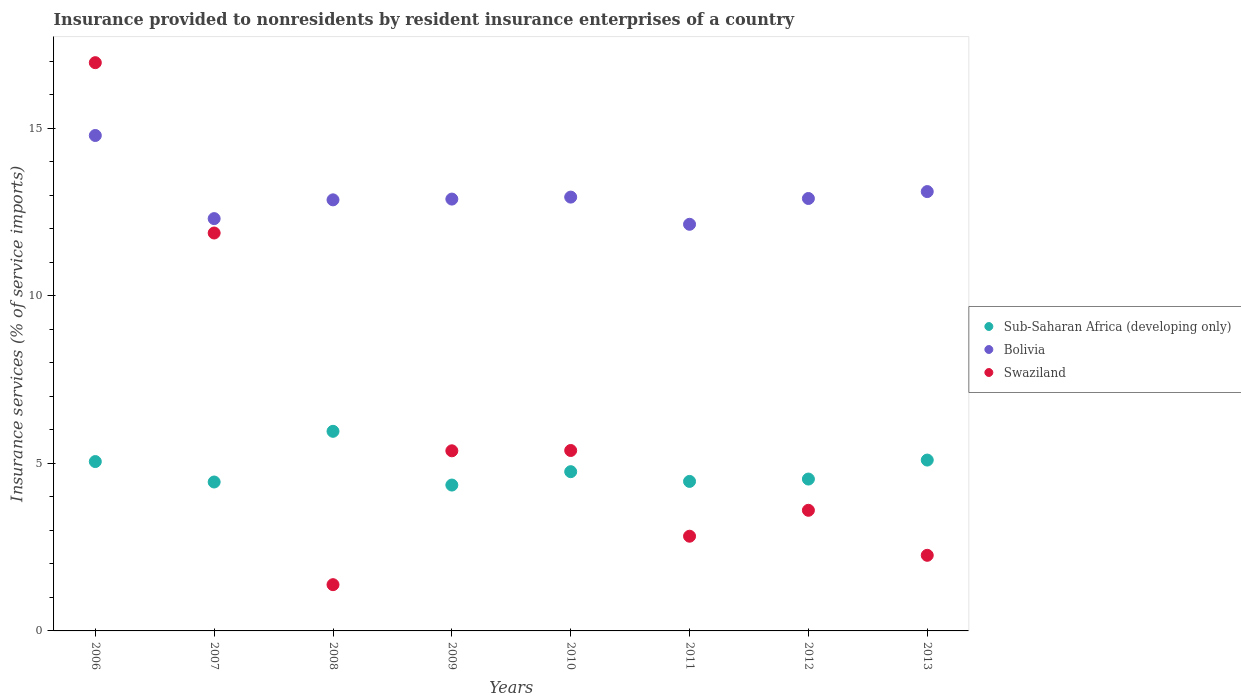What is the insurance provided to nonresidents in Swaziland in 2006?
Give a very brief answer. 16.96. Across all years, what is the maximum insurance provided to nonresidents in Bolivia?
Keep it short and to the point. 14.79. Across all years, what is the minimum insurance provided to nonresidents in Sub-Saharan Africa (developing only)?
Your answer should be very brief. 4.35. What is the total insurance provided to nonresidents in Swaziland in the graph?
Give a very brief answer. 49.66. What is the difference between the insurance provided to nonresidents in Sub-Saharan Africa (developing only) in 2009 and that in 2011?
Give a very brief answer. -0.11. What is the difference between the insurance provided to nonresidents in Swaziland in 2012 and the insurance provided to nonresidents in Sub-Saharan Africa (developing only) in 2009?
Provide a short and direct response. -0.75. What is the average insurance provided to nonresidents in Sub-Saharan Africa (developing only) per year?
Offer a very short reply. 4.83. In the year 2009, what is the difference between the insurance provided to nonresidents in Sub-Saharan Africa (developing only) and insurance provided to nonresidents in Swaziland?
Provide a succinct answer. -1.02. What is the ratio of the insurance provided to nonresidents in Swaziland in 2010 to that in 2011?
Offer a terse response. 1.91. Is the insurance provided to nonresidents in Swaziland in 2006 less than that in 2007?
Provide a short and direct response. No. What is the difference between the highest and the second highest insurance provided to nonresidents in Bolivia?
Make the answer very short. 1.67. What is the difference between the highest and the lowest insurance provided to nonresidents in Swaziland?
Your answer should be compact. 15.58. Is the sum of the insurance provided to nonresidents in Bolivia in 2008 and 2009 greater than the maximum insurance provided to nonresidents in Swaziland across all years?
Your answer should be compact. Yes. Is it the case that in every year, the sum of the insurance provided to nonresidents in Swaziland and insurance provided to nonresidents in Sub-Saharan Africa (developing only)  is greater than the insurance provided to nonresidents in Bolivia?
Provide a succinct answer. No. Is the insurance provided to nonresidents in Swaziland strictly less than the insurance provided to nonresidents in Bolivia over the years?
Ensure brevity in your answer.  No. How many dotlines are there?
Give a very brief answer. 3. How many years are there in the graph?
Give a very brief answer. 8. Does the graph contain any zero values?
Offer a very short reply. No. Where does the legend appear in the graph?
Your response must be concise. Center right. How many legend labels are there?
Provide a succinct answer. 3. What is the title of the graph?
Give a very brief answer. Insurance provided to nonresidents by resident insurance enterprises of a country. What is the label or title of the Y-axis?
Make the answer very short. Insurance services (% of service imports). What is the Insurance services (% of service imports) in Sub-Saharan Africa (developing only) in 2006?
Offer a terse response. 5.05. What is the Insurance services (% of service imports) in Bolivia in 2006?
Provide a short and direct response. 14.79. What is the Insurance services (% of service imports) of Swaziland in 2006?
Make the answer very short. 16.96. What is the Insurance services (% of service imports) in Sub-Saharan Africa (developing only) in 2007?
Keep it short and to the point. 4.44. What is the Insurance services (% of service imports) in Bolivia in 2007?
Give a very brief answer. 12.31. What is the Insurance services (% of service imports) in Swaziland in 2007?
Your answer should be very brief. 11.88. What is the Insurance services (% of service imports) in Sub-Saharan Africa (developing only) in 2008?
Give a very brief answer. 5.96. What is the Insurance services (% of service imports) of Bolivia in 2008?
Ensure brevity in your answer.  12.87. What is the Insurance services (% of service imports) of Swaziland in 2008?
Provide a succinct answer. 1.38. What is the Insurance services (% of service imports) in Sub-Saharan Africa (developing only) in 2009?
Your answer should be very brief. 4.35. What is the Insurance services (% of service imports) of Bolivia in 2009?
Provide a succinct answer. 12.89. What is the Insurance services (% of service imports) in Swaziland in 2009?
Give a very brief answer. 5.38. What is the Insurance services (% of service imports) in Sub-Saharan Africa (developing only) in 2010?
Provide a short and direct response. 4.75. What is the Insurance services (% of service imports) in Bolivia in 2010?
Offer a terse response. 12.95. What is the Insurance services (% of service imports) in Swaziland in 2010?
Provide a succinct answer. 5.38. What is the Insurance services (% of service imports) of Sub-Saharan Africa (developing only) in 2011?
Your answer should be compact. 4.46. What is the Insurance services (% of service imports) of Bolivia in 2011?
Give a very brief answer. 12.14. What is the Insurance services (% of service imports) in Swaziland in 2011?
Offer a terse response. 2.83. What is the Insurance services (% of service imports) of Sub-Saharan Africa (developing only) in 2012?
Offer a terse response. 4.53. What is the Insurance services (% of service imports) in Bolivia in 2012?
Give a very brief answer. 12.91. What is the Insurance services (% of service imports) in Swaziland in 2012?
Provide a succinct answer. 3.6. What is the Insurance services (% of service imports) in Sub-Saharan Africa (developing only) in 2013?
Offer a very short reply. 5.1. What is the Insurance services (% of service imports) in Bolivia in 2013?
Provide a succinct answer. 13.11. What is the Insurance services (% of service imports) in Swaziland in 2013?
Your response must be concise. 2.26. Across all years, what is the maximum Insurance services (% of service imports) in Sub-Saharan Africa (developing only)?
Keep it short and to the point. 5.96. Across all years, what is the maximum Insurance services (% of service imports) of Bolivia?
Give a very brief answer. 14.79. Across all years, what is the maximum Insurance services (% of service imports) of Swaziland?
Keep it short and to the point. 16.96. Across all years, what is the minimum Insurance services (% of service imports) in Sub-Saharan Africa (developing only)?
Provide a succinct answer. 4.35. Across all years, what is the minimum Insurance services (% of service imports) of Bolivia?
Your response must be concise. 12.14. Across all years, what is the minimum Insurance services (% of service imports) in Swaziland?
Keep it short and to the point. 1.38. What is the total Insurance services (% of service imports) of Sub-Saharan Africa (developing only) in the graph?
Provide a succinct answer. 38.66. What is the total Insurance services (% of service imports) of Bolivia in the graph?
Your answer should be compact. 103.95. What is the total Insurance services (% of service imports) in Swaziland in the graph?
Ensure brevity in your answer.  49.66. What is the difference between the Insurance services (% of service imports) of Sub-Saharan Africa (developing only) in 2006 and that in 2007?
Offer a terse response. 0.61. What is the difference between the Insurance services (% of service imports) in Bolivia in 2006 and that in 2007?
Your answer should be very brief. 2.48. What is the difference between the Insurance services (% of service imports) of Swaziland in 2006 and that in 2007?
Offer a terse response. 5.08. What is the difference between the Insurance services (% of service imports) in Sub-Saharan Africa (developing only) in 2006 and that in 2008?
Provide a short and direct response. -0.9. What is the difference between the Insurance services (% of service imports) of Bolivia in 2006 and that in 2008?
Your response must be concise. 1.92. What is the difference between the Insurance services (% of service imports) in Swaziland in 2006 and that in 2008?
Offer a terse response. 15.58. What is the difference between the Insurance services (% of service imports) in Sub-Saharan Africa (developing only) in 2006 and that in 2009?
Provide a short and direct response. 0.7. What is the difference between the Insurance services (% of service imports) of Bolivia in 2006 and that in 2009?
Give a very brief answer. 1.9. What is the difference between the Insurance services (% of service imports) in Swaziland in 2006 and that in 2009?
Keep it short and to the point. 11.58. What is the difference between the Insurance services (% of service imports) in Sub-Saharan Africa (developing only) in 2006 and that in 2010?
Offer a very short reply. 0.3. What is the difference between the Insurance services (% of service imports) in Bolivia in 2006 and that in 2010?
Your answer should be very brief. 1.84. What is the difference between the Insurance services (% of service imports) in Swaziland in 2006 and that in 2010?
Make the answer very short. 11.57. What is the difference between the Insurance services (% of service imports) in Sub-Saharan Africa (developing only) in 2006 and that in 2011?
Give a very brief answer. 0.59. What is the difference between the Insurance services (% of service imports) in Bolivia in 2006 and that in 2011?
Your response must be concise. 2.65. What is the difference between the Insurance services (% of service imports) in Swaziland in 2006 and that in 2011?
Provide a succinct answer. 14.13. What is the difference between the Insurance services (% of service imports) in Sub-Saharan Africa (developing only) in 2006 and that in 2012?
Provide a short and direct response. 0.52. What is the difference between the Insurance services (% of service imports) in Bolivia in 2006 and that in 2012?
Provide a succinct answer. 1.88. What is the difference between the Insurance services (% of service imports) in Swaziland in 2006 and that in 2012?
Your answer should be compact. 13.36. What is the difference between the Insurance services (% of service imports) of Sub-Saharan Africa (developing only) in 2006 and that in 2013?
Your response must be concise. -0.04. What is the difference between the Insurance services (% of service imports) of Bolivia in 2006 and that in 2013?
Keep it short and to the point. 1.67. What is the difference between the Insurance services (% of service imports) of Swaziland in 2006 and that in 2013?
Give a very brief answer. 14.7. What is the difference between the Insurance services (% of service imports) of Sub-Saharan Africa (developing only) in 2007 and that in 2008?
Make the answer very short. -1.51. What is the difference between the Insurance services (% of service imports) of Bolivia in 2007 and that in 2008?
Your answer should be very brief. -0.56. What is the difference between the Insurance services (% of service imports) in Swaziland in 2007 and that in 2008?
Offer a terse response. 10.5. What is the difference between the Insurance services (% of service imports) in Sub-Saharan Africa (developing only) in 2007 and that in 2009?
Offer a very short reply. 0.09. What is the difference between the Insurance services (% of service imports) of Bolivia in 2007 and that in 2009?
Ensure brevity in your answer.  -0.58. What is the difference between the Insurance services (% of service imports) in Swaziland in 2007 and that in 2009?
Offer a terse response. 6.5. What is the difference between the Insurance services (% of service imports) of Sub-Saharan Africa (developing only) in 2007 and that in 2010?
Provide a short and direct response. -0.31. What is the difference between the Insurance services (% of service imports) of Bolivia in 2007 and that in 2010?
Provide a succinct answer. -0.64. What is the difference between the Insurance services (% of service imports) in Swaziland in 2007 and that in 2010?
Offer a very short reply. 6.49. What is the difference between the Insurance services (% of service imports) in Sub-Saharan Africa (developing only) in 2007 and that in 2011?
Provide a short and direct response. -0.02. What is the difference between the Insurance services (% of service imports) in Bolivia in 2007 and that in 2011?
Your answer should be very brief. 0.17. What is the difference between the Insurance services (% of service imports) in Swaziland in 2007 and that in 2011?
Offer a very short reply. 9.05. What is the difference between the Insurance services (% of service imports) of Sub-Saharan Africa (developing only) in 2007 and that in 2012?
Provide a succinct answer. -0.09. What is the difference between the Insurance services (% of service imports) in Bolivia in 2007 and that in 2012?
Offer a terse response. -0.6. What is the difference between the Insurance services (% of service imports) of Swaziland in 2007 and that in 2012?
Give a very brief answer. 8.28. What is the difference between the Insurance services (% of service imports) in Sub-Saharan Africa (developing only) in 2007 and that in 2013?
Your response must be concise. -0.65. What is the difference between the Insurance services (% of service imports) in Bolivia in 2007 and that in 2013?
Your response must be concise. -0.81. What is the difference between the Insurance services (% of service imports) in Swaziland in 2007 and that in 2013?
Your answer should be compact. 9.62. What is the difference between the Insurance services (% of service imports) of Sub-Saharan Africa (developing only) in 2008 and that in 2009?
Your answer should be very brief. 1.6. What is the difference between the Insurance services (% of service imports) of Bolivia in 2008 and that in 2009?
Your answer should be compact. -0.02. What is the difference between the Insurance services (% of service imports) of Swaziland in 2008 and that in 2009?
Your answer should be compact. -4. What is the difference between the Insurance services (% of service imports) in Sub-Saharan Africa (developing only) in 2008 and that in 2010?
Your response must be concise. 1.2. What is the difference between the Insurance services (% of service imports) in Bolivia in 2008 and that in 2010?
Your answer should be very brief. -0.08. What is the difference between the Insurance services (% of service imports) of Swaziland in 2008 and that in 2010?
Give a very brief answer. -4. What is the difference between the Insurance services (% of service imports) of Sub-Saharan Africa (developing only) in 2008 and that in 2011?
Your answer should be very brief. 1.49. What is the difference between the Insurance services (% of service imports) in Bolivia in 2008 and that in 2011?
Offer a terse response. 0.73. What is the difference between the Insurance services (% of service imports) of Swaziland in 2008 and that in 2011?
Give a very brief answer. -1.45. What is the difference between the Insurance services (% of service imports) of Sub-Saharan Africa (developing only) in 2008 and that in 2012?
Your answer should be compact. 1.42. What is the difference between the Insurance services (% of service imports) of Bolivia in 2008 and that in 2012?
Give a very brief answer. -0.04. What is the difference between the Insurance services (% of service imports) in Swaziland in 2008 and that in 2012?
Provide a short and direct response. -2.22. What is the difference between the Insurance services (% of service imports) of Sub-Saharan Africa (developing only) in 2008 and that in 2013?
Your answer should be very brief. 0.86. What is the difference between the Insurance services (% of service imports) in Bolivia in 2008 and that in 2013?
Your answer should be very brief. -0.25. What is the difference between the Insurance services (% of service imports) of Swaziland in 2008 and that in 2013?
Your answer should be very brief. -0.88. What is the difference between the Insurance services (% of service imports) in Sub-Saharan Africa (developing only) in 2009 and that in 2010?
Your response must be concise. -0.4. What is the difference between the Insurance services (% of service imports) in Bolivia in 2009 and that in 2010?
Provide a succinct answer. -0.06. What is the difference between the Insurance services (% of service imports) of Swaziland in 2009 and that in 2010?
Your answer should be very brief. -0.01. What is the difference between the Insurance services (% of service imports) of Sub-Saharan Africa (developing only) in 2009 and that in 2011?
Offer a very short reply. -0.11. What is the difference between the Insurance services (% of service imports) of Bolivia in 2009 and that in 2011?
Offer a very short reply. 0.75. What is the difference between the Insurance services (% of service imports) in Swaziland in 2009 and that in 2011?
Provide a short and direct response. 2.55. What is the difference between the Insurance services (% of service imports) of Sub-Saharan Africa (developing only) in 2009 and that in 2012?
Keep it short and to the point. -0.18. What is the difference between the Insurance services (% of service imports) in Bolivia in 2009 and that in 2012?
Your response must be concise. -0.02. What is the difference between the Insurance services (% of service imports) of Swaziland in 2009 and that in 2012?
Provide a succinct answer. 1.78. What is the difference between the Insurance services (% of service imports) in Sub-Saharan Africa (developing only) in 2009 and that in 2013?
Make the answer very short. -0.75. What is the difference between the Insurance services (% of service imports) in Bolivia in 2009 and that in 2013?
Your answer should be compact. -0.22. What is the difference between the Insurance services (% of service imports) of Swaziland in 2009 and that in 2013?
Offer a very short reply. 3.12. What is the difference between the Insurance services (% of service imports) in Sub-Saharan Africa (developing only) in 2010 and that in 2011?
Your response must be concise. 0.29. What is the difference between the Insurance services (% of service imports) in Bolivia in 2010 and that in 2011?
Provide a short and direct response. 0.81. What is the difference between the Insurance services (% of service imports) in Swaziland in 2010 and that in 2011?
Give a very brief answer. 2.56. What is the difference between the Insurance services (% of service imports) of Sub-Saharan Africa (developing only) in 2010 and that in 2012?
Ensure brevity in your answer.  0.22. What is the difference between the Insurance services (% of service imports) in Bolivia in 2010 and that in 2012?
Give a very brief answer. 0.04. What is the difference between the Insurance services (% of service imports) of Swaziland in 2010 and that in 2012?
Your answer should be very brief. 1.78. What is the difference between the Insurance services (% of service imports) of Sub-Saharan Africa (developing only) in 2010 and that in 2013?
Provide a short and direct response. -0.35. What is the difference between the Insurance services (% of service imports) in Bolivia in 2010 and that in 2013?
Keep it short and to the point. -0.16. What is the difference between the Insurance services (% of service imports) in Swaziland in 2010 and that in 2013?
Provide a succinct answer. 3.13. What is the difference between the Insurance services (% of service imports) in Sub-Saharan Africa (developing only) in 2011 and that in 2012?
Give a very brief answer. -0.07. What is the difference between the Insurance services (% of service imports) of Bolivia in 2011 and that in 2012?
Make the answer very short. -0.77. What is the difference between the Insurance services (% of service imports) in Swaziland in 2011 and that in 2012?
Offer a very short reply. -0.77. What is the difference between the Insurance services (% of service imports) in Sub-Saharan Africa (developing only) in 2011 and that in 2013?
Provide a short and direct response. -0.64. What is the difference between the Insurance services (% of service imports) in Bolivia in 2011 and that in 2013?
Make the answer very short. -0.98. What is the difference between the Insurance services (% of service imports) in Swaziland in 2011 and that in 2013?
Give a very brief answer. 0.57. What is the difference between the Insurance services (% of service imports) in Sub-Saharan Africa (developing only) in 2012 and that in 2013?
Offer a terse response. -0.57. What is the difference between the Insurance services (% of service imports) in Bolivia in 2012 and that in 2013?
Offer a terse response. -0.21. What is the difference between the Insurance services (% of service imports) in Swaziland in 2012 and that in 2013?
Your answer should be compact. 1.34. What is the difference between the Insurance services (% of service imports) in Sub-Saharan Africa (developing only) in 2006 and the Insurance services (% of service imports) in Bolivia in 2007?
Your answer should be very brief. -7.25. What is the difference between the Insurance services (% of service imports) in Sub-Saharan Africa (developing only) in 2006 and the Insurance services (% of service imports) in Swaziland in 2007?
Provide a short and direct response. -6.82. What is the difference between the Insurance services (% of service imports) in Bolivia in 2006 and the Insurance services (% of service imports) in Swaziland in 2007?
Make the answer very short. 2.91. What is the difference between the Insurance services (% of service imports) in Sub-Saharan Africa (developing only) in 2006 and the Insurance services (% of service imports) in Bolivia in 2008?
Your response must be concise. -7.81. What is the difference between the Insurance services (% of service imports) of Sub-Saharan Africa (developing only) in 2006 and the Insurance services (% of service imports) of Swaziland in 2008?
Your answer should be very brief. 3.67. What is the difference between the Insurance services (% of service imports) of Bolivia in 2006 and the Insurance services (% of service imports) of Swaziland in 2008?
Offer a terse response. 13.41. What is the difference between the Insurance services (% of service imports) in Sub-Saharan Africa (developing only) in 2006 and the Insurance services (% of service imports) in Bolivia in 2009?
Offer a very short reply. -7.83. What is the difference between the Insurance services (% of service imports) in Sub-Saharan Africa (developing only) in 2006 and the Insurance services (% of service imports) in Swaziland in 2009?
Give a very brief answer. -0.32. What is the difference between the Insurance services (% of service imports) of Bolivia in 2006 and the Insurance services (% of service imports) of Swaziland in 2009?
Your response must be concise. 9.41. What is the difference between the Insurance services (% of service imports) in Sub-Saharan Africa (developing only) in 2006 and the Insurance services (% of service imports) in Bolivia in 2010?
Provide a short and direct response. -7.89. What is the difference between the Insurance services (% of service imports) of Sub-Saharan Africa (developing only) in 2006 and the Insurance services (% of service imports) of Swaziland in 2010?
Make the answer very short. -0.33. What is the difference between the Insurance services (% of service imports) of Bolivia in 2006 and the Insurance services (% of service imports) of Swaziland in 2010?
Give a very brief answer. 9.4. What is the difference between the Insurance services (% of service imports) in Sub-Saharan Africa (developing only) in 2006 and the Insurance services (% of service imports) in Bolivia in 2011?
Ensure brevity in your answer.  -7.08. What is the difference between the Insurance services (% of service imports) in Sub-Saharan Africa (developing only) in 2006 and the Insurance services (% of service imports) in Swaziland in 2011?
Your answer should be very brief. 2.23. What is the difference between the Insurance services (% of service imports) of Bolivia in 2006 and the Insurance services (% of service imports) of Swaziland in 2011?
Provide a short and direct response. 11.96. What is the difference between the Insurance services (% of service imports) of Sub-Saharan Africa (developing only) in 2006 and the Insurance services (% of service imports) of Bolivia in 2012?
Your response must be concise. -7.85. What is the difference between the Insurance services (% of service imports) in Sub-Saharan Africa (developing only) in 2006 and the Insurance services (% of service imports) in Swaziland in 2012?
Ensure brevity in your answer.  1.45. What is the difference between the Insurance services (% of service imports) in Bolivia in 2006 and the Insurance services (% of service imports) in Swaziland in 2012?
Offer a terse response. 11.19. What is the difference between the Insurance services (% of service imports) of Sub-Saharan Africa (developing only) in 2006 and the Insurance services (% of service imports) of Bolivia in 2013?
Provide a succinct answer. -8.06. What is the difference between the Insurance services (% of service imports) in Sub-Saharan Africa (developing only) in 2006 and the Insurance services (% of service imports) in Swaziland in 2013?
Provide a short and direct response. 2.8. What is the difference between the Insurance services (% of service imports) of Bolivia in 2006 and the Insurance services (% of service imports) of Swaziland in 2013?
Provide a succinct answer. 12.53. What is the difference between the Insurance services (% of service imports) of Sub-Saharan Africa (developing only) in 2007 and the Insurance services (% of service imports) of Bolivia in 2008?
Provide a short and direct response. -8.42. What is the difference between the Insurance services (% of service imports) of Sub-Saharan Africa (developing only) in 2007 and the Insurance services (% of service imports) of Swaziland in 2008?
Give a very brief answer. 3.06. What is the difference between the Insurance services (% of service imports) in Bolivia in 2007 and the Insurance services (% of service imports) in Swaziland in 2008?
Offer a very short reply. 10.93. What is the difference between the Insurance services (% of service imports) in Sub-Saharan Africa (developing only) in 2007 and the Insurance services (% of service imports) in Bolivia in 2009?
Provide a short and direct response. -8.44. What is the difference between the Insurance services (% of service imports) in Sub-Saharan Africa (developing only) in 2007 and the Insurance services (% of service imports) in Swaziland in 2009?
Provide a short and direct response. -0.93. What is the difference between the Insurance services (% of service imports) in Bolivia in 2007 and the Insurance services (% of service imports) in Swaziland in 2009?
Provide a short and direct response. 6.93. What is the difference between the Insurance services (% of service imports) in Sub-Saharan Africa (developing only) in 2007 and the Insurance services (% of service imports) in Bolivia in 2010?
Ensure brevity in your answer.  -8.5. What is the difference between the Insurance services (% of service imports) in Sub-Saharan Africa (developing only) in 2007 and the Insurance services (% of service imports) in Swaziland in 2010?
Ensure brevity in your answer.  -0.94. What is the difference between the Insurance services (% of service imports) of Bolivia in 2007 and the Insurance services (% of service imports) of Swaziland in 2010?
Offer a terse response. 6.92. What is the difference between the Insurance services (% of service imports) of Sub-Saharan Africa (developing only) in 2007 and the Insurance services (% of service imports) of Bolivia in 2011?
Provide a succinct answer. -7.69. What is the difference between the Insurance services (% of service imports) in Sub-Saharan Africa (developing only) in 2007 and the Insurance services (% of service imports) in Swaziland in 2011?
Your answer should be very brief. 1.62. What is the difference between the Insurance services (% of service imports) of Bolivia in 2007 and the Insurance services (% of service imports) of Swaziland in 2011?
Provide a short and direct response. 9.48. What is the difference between the Insurance services (% of service imports) in Sub-Saharan Africa (developing only) in 2007 and the Insurance services (% of service imports) in Bolivia in 2012?
Offer a terse response. -8.46. What is the difference between the Insurance services (% of service imports) in Sub-Saharan Africa (developing only) in 2007 and the Insurance services (% of service imports) in Swaziland in 2012?
Your response must be concise. 0.84. What is the difference between the Insurance services (% of service imports) of Bolivia in 2007 and the Insurance services (% of service imports) of Swaziland in 2012?
Ensure brevity in your answer.  8.71. What is the difference between the Insurance services (% of service imports) in Sub-Saharan Africa (developing only) in 2007 and the Insurance services (% of service imports) in Bolivia in 2013?
Give a very brief answer. -8.67. What is the difference between the Insurance services (% of service imports) in Sub-Saharan Africa (developing only) in 2007 and the Insurance services (% of service imports) in Swaziland in 2013?
Give a very brief answer. 2.19. What is the difference between the Insurance services (% of service imports) in Bolivia in 2007 and the Insurance services (% of service imports) in Swaziland in 2013?
Your answer should be very brief. 10.05. What is the difference between the Insurance services (% of service imports) in Sub-Saharan Africa (developing only) in 2008 and the Insurance services (% of service imports) in Bolivia in 2009?
Offer a terse response. -6.93. What is the difference between the Insurance services (% of service imports) of Sub-Saharan Africa (developing only) in 2008 and the Insurance services (% of service imports) of Swaziland in 2009?
Give a very brief answer. 0.58. What is the difference between the Insurance services (% of service imports) of Bolivia in 2008 and the Insurance services (% of service imports) of Swaziland in 2009?
Your answer should be very brief. 7.49. What is the difference between the Insurance services (% of service imports) of Sub-Saharan Africa (developing only) in 2008 and the Insurance services (% of service imports) of Bolivia in 2010?
Your answer should be very brief. -6.99. What is the difference between the Insurance services (% of service imports) of Sub-Saharan Africa (developing only) in 2008 and the Insurance services (% of service imports) of Swaziland in 2010?
Keep it short and to the point. 0.57. What is the difference between the Insurance services (% of service imports) in Bolivia in 2008 and the Insurance services (% of service imports) in Swaziland in 2010?
Keep it short and to the point. 7.48. What is the difference between the Insurance services (% of service imports) of Sub-Saharan Africa (developing only) in 2008 and the Insurance services (% of service imports) of Bolivia in 2011?
Keep it short and to the point. -6.18. What is the difference between the Insurance services (% of service imports) of Sub-Saharan Africa (developing only) in 2008 and the Insurance services (% of service imports) of Swaziland in 2011?
Provide a short and direct response. 3.13. What is the difference between the Insurance services (% of service imports) in Bolivia in 2008 and the Insurance services (% of service imports) in Swaziland in 2011?
Your answer should be very brief. 10.04. What is the difference between the Insurance services (% of service imports) in Sub-Saharan Africa (developing only) in 2008 and the Insurance services (% of service imports) in Bolivia in 2012?
Give a very brief answer. -6.95. What is the difference between the Insurance services (% of service imports) of Sub-Saharan Africa (developing only) in 2008 and the Insurance services (% of service imports) of Swaziland in 2012?
Give a very brief answer. 2.36. What is the difference between the Insurance services (% of service imports) of Bolivia in 2008 and the Insurance services (% of service imports) of Swaziland in 2012?
Your answer should be very brief. 9.27. What is the difference between the Insurance services (% of service imports) in Sub-Saharan Africa (developing only) in 2008 and the Insurance services (% of service imports) in Bolivia in 2013?
Ensure brevity in your answer.  -7.16. What is the difference between the Insurance services (% of service imports) in Sub-Saharan Africa (developing only) in 2008 and the Insurance services (% of service imports) in Swaziland in 2013?
Your answer should be compact. 3.7. What is the difference between the Insurance services (% of service imports) of Bolivia in 2008 and the Insurance services (% of service imports) of Swaziland in 2013?
Make the answer very short. 10.61. What is the difference between the Insurance services (% of service imports) in Sub-Saharan Africa (developing only) in 2009 and the Insurance services (% of service imports) in Bolivia in 2010?
Provide a succinct answer. -8.59. What is the difference between the Insurance services (% of service imports) of Sub-Saharan Africa (developing only) in 2009 and the Insurance services (% of service imports) of Swaziland in 2010?
Your answer should be very brief. -1.03. What is the difference between the Insurance services (% of service imports) in Bolivia in 2009 and the Insurance services (% of service imports) in Swaziland in 2010?
Your answer should be very brief. 7.5. What is the difference between the Insurance services (% of service imports) of Sub-Saharan Africa (developing only) in 2009 and the Insurance services (% of service imports) of Bolivia in 2011?
Your answer should be compact. -7.78. What is the difference between the Insurance services (% of service imports) in Sub-Saharan Africa (developing only) in 2009 and the Insurance services (% of service imports) in Swaziland in 2011?
Offer a very short reply. 1.53. What is the difference between the Insurance services (% of service imports) of Bolivia in 2009 and the Insurance services (% of service imports) of Swaziland in 2011?
Make the answer very short. 10.06. What is the difference between the Insurance services (% of service imports) of Sub-Saharan Africa (developing only) in 2009 and the Insurance services (% of service imports) of Bolivia in 2012?
Your answer should be very brief. -8.55. What is the difference between the Insurance services (% of service imports) of Sub-Saharan Africa (developing only) in 2009 and the Insurance services (% of service imports) of Swaziland in 2012?
Make the answer very short. 0.75. What is the difference between the Insurance services (% of service imports) of Bolivia in 2009 and the Insurance services (% of service imports) of Swaziland in 2012?
Ensure brevity in your answer.  9.29. What is the difference between the Insurance services (% of service imports) in Sub-Saharan Africa (developing only) in 2009 and the Insurance services (% of service imports) in Bolivia in 2013?
Keep it short and to the point. -8.76. What is the difference between the Insurance services (% of service imports) of Sub-Saharan Africa (developing only) in 2009 and the Insurance services (% of service imports) of Swaziland in 2013?
Give a very brief answer. 2.1. What is the difference between the Insurance services (% of service imports) in Bolivia in 2009 and the Insurance services (% of service imports) in Swaziland in 2013?
Your answer should be compact. 10.63. What is the difference between the Insurance services (% of service imports) of Sub-Saharan Africa (developing only) in 2010 and the Insurance services (% of service imports) of Bolivia in 2011?
Your answer should be compact. -7.38. What is the difference between the Insurance services (% of service imports) of Sub-Saharan Africa (developing only) in 2010 and the Insurance services (% of service imports) of Swaziland in 2011?
Ensure brevity in your answer.  1.93. What is the difference between the Insurance services (% of service imports) in Bolivia in 2010 and the Insurance services (% of service imports) in Swaziland in 2011?
Give a very brief answer. 10.12. What is the difference between the Insurance services (% of service imports) of Sub-Saharan Africa (developing only) in 2010 and the Insurance services (% of service imports) of Bolivia in 2012?
Provide a succinct answer. -8.15. What is the difference between the Insurance services (% of service imports) of Sub-Saharan Africa (developing only) in 2010 and the Insurance services (% of service imports) of Swaziland in 2012?
Your response must be concise. 1.15. What is the difference between the Insurance services (% of service imports) of Bolivia in 2010 and the Insurance services (% of service imports) of Swaziland in 2012?
Offer a very short reply. 9.35. What is the difference between the Insurance services (% of service imports) of Sub-Saharan Africa (developing only) in 2010 and the Insurance services (% of service imports) of Bolivia in 2013?
Offer a terse response. -8.36. What is the difference between the Insurance services (% of service imports) in Sub-Saharan Africa (developing only) in 2010 and the Insurance services (% of service imports) in Swaziland in 2013?
Offer a terse response. 2.5. What is the difference between the Insurance services (% of service imports) of Bolivia in 2010 and the Insurance services (% of service imports) of Swaziland in 2013?
Provide a succinct answer. 10.69. What is the difference between the Insurance services (% of service imports) in Sub-Saharan Africa (developing only) in 2011 and the Insurance services (% of service imports) in Bolivia in 2012?
Ensure brevity in your answer.  -8.44. What is the difference between the Insurance services (% of service imports) in Sub-Saharan Africa (developing only) in 2011 and the Insurance services (% of service imports) in Swaziland in 2012?
Offer a terse response. 0.86. What is the difference between the Insurance services (% of service imports) in Bolivia in 2011 and the Insurance services (% of service imports) in Swaziland in 2012?
Offer a terse response. 8.54. What is the difference between the Insurance services (% of service imports) of Sub-Saharan Africa (developing only) in 2011 and the Insurance services (% of service imports) of Bolivia in 2013?
Your answer should be compact. -8.65. What is the difference between the Insurance services (% of service imports) of Sub-Saharan Africa (developing only) in 2011 and the Insurance services (% of service imports) of Swaziland in 2013?
Give a very brief answer. 2.21. What is the difference between the Insurance services (% of service imports) in Bolivia in 2011 and the Insurance services (% of service imports) in Swaziland in 2013?
Your answer should be very brief. 9.88. What is the difference between the Insurance services (% of service imports) of Sub-Saharan Africa (developing only) in 2012 and the Insurance services (% of service imports) of Bolivia in 2013?
Provide a short and direct response. -8.58. What is the difference between the Insurance services (% of service imports) of Sub-Saharan Africa (developing only) in 2012 and the Insurance services (% of service imports) of Swaziland in 2013?
Offer a very short reply. 2.28. What is the difference between the Insurance services (% of service imports) of Bolivia in 2012 and the Insurance services (% of service imports) of Swaziland in 2013?
Your response must be concise. 10.65. What is the average Insurance services (% of service imports) of Sub-Saharan Africa (developing only) per year?
Your answer should be very brief. 4.83. What is the average Insurance services (% of service imports) of Bolivia per year?
Offer a terse response. 12.99. What is the average Insurance services (% of service imports) in Swaziland per year?
Provide a succinct answer. 6.21. In the year 2006, what is the difference between the Insurance services (% of service imports) of Sub-Saharan Africa (developing only) and Insurance services (% of service imports) of Bolivia?
Keep it short and to the point. -9.73. In the year 2006, what is the difference between the Insurance services (% of service imports) of Sub-Saharan Africa (developing only) and Insurance services (% of service imports) of Swaziland?
Your response must be concise. -11.91. In the year 2006, what is the difference between the Insurance services (% of service imports) in Bolivia and Insurance services (% of service imports) in Swaziland?
Your answer should be very brief. -2.17. In the year 2007, what is the difference between the Insurance services (% of service imports) of Sub-Saharan Africa (developing only) and Insurance services (% of service imports) of Bolivia?
Your answer should be compact. -7.86. In the year 2007, what is the difference between the Insurance services (% of service imports) in Sub-Saharan Africa (developing only) and Insurance services (% of service imports) in Swaziland?
Make the answer very short. -7.43. In the year 2007, what is the difference between the Insurance services (% of service imports) of Bolivia and Insurance services (% of service imports) of Swaziland?
Offer a terse response. 0.43. In the year 2008, what is the difference between the Insurance services (% of service imports) in Sub-Saharan Africa (developing only) and Insurance services (% of service imports) in Bolivia?
Keep it short and to the point. -6.91. In the year 2008, what is the difference between the Insurance services (% of service imports) of Sub-Saharan Africa (developing only) and Insurance services (% of service imports) of Swaziland?
Offer a very short reply. 4.58. In the year 2008, what is the difference between the Insurance services (% of service imports) in Bolivia and Insurance services (% of service imports) in Swaziland?
Your answer should be very brief. 11.49. In the year 2009, what is the difference between the Insurance services (% of service imports) in Sub-Saharan Africa (developing only) and Insurance services (% of service imports) in Bolivia?
Your answer should be very brief. -8.54. In the year 2009, what is the difference between the Insurance services (% of service imports) of Sub-Saharan Africa (developing only) and Insurance services (% of service imports) of Swaziland?
Offer a very short reply. -1.02. In the year 2009, what is the difference between the Insurance services (% of service imports) in Bolivia and Insurance services (% of service imports) in Swaziland?
Provide a short and direct response. 7.51. In the year 2010, what is the difference between the Insurance services (% of service imports) of Sub-Saharan Africa (developing only) and Insurance services (% of service imports) of Bolivia?
Provide a succinct answer. -8.19. In the year 2010, what is the difference between the Insurance services (% of service imports) of Sub-Saharan Africa (developing only) and Insurance services (% of service imports) of Swaziland?
Offer a very short reply. -0.63. In the year 2010, what is the difference between the Insurance services (% of service imports) of Bolivia and Insurance services (% of service imports) of Swaziland?
Give a very brief answer. 7.56. In the year 2011, what is the difference between the Insurance services (% of service imports) of Sub-Saharan Africa (developing only) and Insurance services (% of service imports) of Bolivia?
Provide a short and direct response. -7.67. In the year 2011, what is the difference between the Insurance services (% of service imports) in Sub-Saharan Africa (developing only) and Insurance services (% of service imports) in Swaziland?
Offer a terse response. 1.64. In the year 2011, what is the difference between the Insurance services (% of service imports) of Bolivia and Insurance services (% of service imports) of Swaziland?
Your answer should be very brief. 9.31. In the year 2012, what is the difference between the Insurance services (% of service imports) of Sub-Saharan Africa (developing only) and Insurance services (% of service imports) of Bolivia?
Make the answer very short. -8.37. In the year 2012, what is the difference between the Insurance services (% of service imports) of Sub-Saharan Africa (developing only) and Insurance services (% of service imports) of Swaziland?
Keep it short and to the point. 0.93. In the year 2012, what is the difference between the Insurance services (% of service imports) in Bolivia and Insurance services (% of service imports) in Swaziland?
Keep it short and to the point. 9.31. In the year 2013, what is the difference between the Insurance services (% of service imports) of Sub-Saharan Africa (developing only) and Insurance services (% of service imports) of Bolivia?
Your answer should be very brief. -8.01. In the year 2013, what is the difference between the Insurance services (% of service imports) in Sub-Saharan Africa (developing only) and Insurance services (% of service imports) in Swaziland?
Give a very brief answer. 2.84. In the year 2013, what is the difference between the Insurance services (% of service imports) in Bolivia and Insurance services (% of service imports) in Swaziland?
Give a very brief answer. 10.86. What is the ratio of the Insurance services (% of service imports) of Sub-Saharan Africa (developing only) in 2006 to that in 2007?
Your answer should be compact. 1.14. What is the ratio of the Insurance services (% of service imports) of Bolivia in 2006 to that in 2007?
Your answer should be compact. 1.2. What is the ratio of the Insurance services (% of service imports) of Swaziland in 2006 to that in 2007?
Make the answer very short. 1.43. What is the ratio of the Insurance services (% of service imports) in Sub-Saharan Africa (developing only) in 2006 to that in 2008?
Keep it short and to the point. 0.85. What is the ratio of the Insurance services (% of service imports) in Bolivia in 2006 to that in 2008?
Offer a very short reply. 1.15. What is the ratio of the Insurance services (% of service imports) of Swaziland in 2006 to that in 2008?
Your response must be concise. 12.29. What is the ratio of the Insurance services (% of service imports) in Sub-Saharan Africa (developing only) in 2006 to that in 2009?
Provide a short and direct response. 1.16. What is the ratio of the Insurance services (% of service imports) of Bolivia in 2006 to that in 2009?
Offer a very short reply. 1.15. What is the ratio of the Insurance services (% of service imports) of Swaziland in 2006 to that in 2009?
Offer a very short reply. 3.15. What is the ratio of the Insurance services (% of service imports) of Sub-Saharan Africa (developing only) in 2006 to that in 2010?
Provide a succinct answer. 1.06. What is the ratio of the Insurance services (% of service imports) in Bolivia in 2006 to that in 2010?
Provide a succinct answer. 1.14. What is the ratio of the Insurance services (% of service imports) in Swaziland in 2006 to that in 2010?
Your answer should be very brief. 3.15. What is the ratio of the Insurance services (% of service imports) of Sub-Saharan Africa (developing only) in 2006 to that in 2011?
Your answer should be very brief. 1.13. What is the ratio of the Insurance services (% of service imports) in Bolivia in 2006 to that in 2011?
Your answer should be very brief. 1.22. What is the ratio of the Insurance services (% of service imports) of Swaziland in 2006 to that in 2011?
Provide a succinct answer. 6. What is the ratio of the Insurance services (% of service imports) of Sub-Saharan Africa (developing only) in 2006 to that in 2012?
Ensure brevity in your answer.  1.12. What is the ratio of the Insurance services (% of service imports) of Bolivia in 2006 to that in 2012?
Ensure brevity in your answer.  1.15. What is the ratio of the Insurance services (% of service imports) of Swaziland in 2006 to that in 2012?
Make the answer very short. 4.71. What is the ratio of the Insurance services (% of service imports) of Bolivia in 2006 to that in 2013?
Keep it short and to the point. 1.13. What is the ratio of the Insurance services (% of service imports) in Swaziland in 2006 to that in 2013?
Keep it short and to the point. 7.52. What is the ratio of the Insurance services (% of service imports) of Sub-Saharan Africa (developing only) in 2007 to that in 2008?
Offer a very short reply. 0.75. What is the ratio of the Insurance services (% of service imports) of Bolivia in 2007 to that in 2008?
Provide a short and direct response. 0.96. What is the ratio of the Insurance services (% of service imports) of Swaziland in 2007 to that in 2008?
Make the answer very short. 8.6. What is the ratio of the Insurance services (% of service imports) of Sub-Saharan Africa (developing only) in 2007 to that in 2009?
Provide a short and direct response. 1.02. What is the ratio of the Insurance services (% of service imports) in Bolivia in 2007 to that in 2009?
Your response must be concise. 0.95. What is the ratio of the Insurance services (% of service imports) of Swaziland in 2007 to that in 2009?
Keep it short and to the point. 2.21. What is the ratio of the Insurance services (% of service imports) of Sub-Saharan Africa (developing only) in 2007 to that in 2010?
Keep it short and to the point. 0.94. What is the ratio of the Insurance services (% of service imports) of Bolivia in 2007 to that in 2010?
Provide a short and direct response. 0.95. What is the ratio of the Insurance services (% of service imports) in Swaziland in 2007 to that in 2010?
Give a very brief answer. 2.21. What is the ratio of the Insurance services (% of service imports) of Swaziland in 2007 to that in 2011?
Make the answer very short. 4.2. What is the ratio of the Insurance services (% of service imports) in Sub-Saharan Africa (developing only) in 2007 to that in 2012?
Ensure brevity in your answer.  0.98. What is the ratio of the Insurance services (% of service imports) of Bolivia in 2007 to that in 2012?
Ensure brevity in your answer.  0.95. What is the ratio of the Insurance services (% of service imports) of Swaziland in 2007 to that in 2012?
Give a very brief answer. 3.3. What is the ratio of the Insurance services (% of service imports) in Sub-Saharan Africa (developing only) in 2007 to that in 2013?
Offer a very short reply. 0.87. What is the ratio of the Insurance services (% of service imports) of Bolivia in 2007 to that in 2013?
Keep it short and to the point. 0.94. What is the ratio of the Insurance services (% of service imports) in Swaziland in 2007 to that in 2013?
Keep it short and to the point. 5.26. What is the ratio of the Insurance services (% of service imports) in Sub-Saharan Africa (developing only) in 2008 to that in 2009?
Provide a succinct answer. 1.37. What is the ratio of the Insurance services (% of service imports) of Swaziland in 2008 to that in 2009?
Your response must be concise. 0.26. What is the ratio of the Insurance services (% of service imports) in Sub-Saharan Africa (developing only) in 2008 to that in 2010?
Your answer should be compact. 1.25. What is the ratio of the Insurance services (% of service imports) in Bolivia in 2008 to that in 2010?
Your answer should be very brief. 0.99. What is the ratio of the Insurance services (% of service imports) of Swaziland in 2008 to that in 2010?
Your response must be concise. 0.26. What is the ratio of the Insurance services (% of service imports) in Sub-Saharan Africa (developing only) in 2008 to that in 2011?
Offer a terse response. 1.33. What is the ratio of the Insurance services (% of service imports) of Bolivia in 2008 to that in 2011?
Provide a succinct answer. 1.06. What is the ratio of the Insurance services (% of service imports) of Swaziland in 2008 to that in 2011?
Your answer should be compact. 0.49. What is the ratio of the Insurance services (% of service imports) in Sub-Saharan Africa (developing only) in 2008 to that in 2012?
Offer a terse response. 1.31. What is the ratio of the Insurance services (% of service imports) of Swaziland in 2008 to that in 2012?
Ensure brevity in your answer.  0.38. What is the ratio of the Insurance services (% of service imports) of Sub-Saharan Africa (developing only) in 2008 to that in 2013?
Your answer should be compact. 1.17. What is the ratio of the Insurance services (% of service imports) in Bolivia in 2008 to that in 2013?
Ensure brevity in your answer.  0.98. What is the ratio of the Insurance services (% of service imports) in Swaziland in 2008 to that in 2013?
Your response must be concise. 0.61. What is the ratio of the Insurance services (% of service imports) of Sub-Saharan Africa (developing only) in 2009 to that in 2010?
Keep it short and to the point. 0.92. What is the ratio of the Insurance services (% of service imports) of Bolivia in 2009 to that in 2010?
Your answer should be compact. 1. What is the ratio of the Insurance services (% of service imports) of Swaziland in 2009 to that in 2010?
Your answer should be very brief. 1. What is the ratio of the Insurance services (% of service imports) of Sub-Saharan Africa (developing only) in 2009 to that in 2011?
Give a very brief answer. 0.98. What is the ratio of the Insurance services (% of service imports) in Bolivia in 2009 to that in 2011?
Give a very brief answer. 1.06. What is the ratio of the Insurance services (% of service imports) of Swaziland in 2009 to that in 2011?
Make the answer very short. 1.9. What is the ratio of the Insurance services (% of service imports) of Sub-Saharan Africa (developing only) in 2009 to that in 2012?
Your response must be concise. 0.96. What is the ratio of the Insurance services (% of service imports) in Swaziland in 2009 to that in 2012?
Your answer should be very brief. 1.49. What is the ratio of the Insurance services (% of service imports) in Sub-Saharan Africa (developing only) in 2009 to that in 2013?
Give a very brief answer. 0.85. What is the ratio of the Insurance services (% of service imports) of Bolivia in 2009 to that in 2013?
Give a very brief answer. 0.98. What is the ratio of the Insurance services (% of service imports) of Swaziland in 2009 to that in 2013?
Offer a very short reply. 2.38. What is the ratio of the Insurance services (% of service imports) of Sub-Saharan Africa (developing only) in 2010 to that in 2011?
Your answer should be very brief. 1.06. What is the ratio of the Insurance services (% of service imports) of Bolivia in 2010 to that in 2011?
Offer a very short reply. 1.07. What is the ratio of the Insurance services (% of service imports) of Swaziland in 2010 to that in 2011?
Make the answer very short. 1.91. What is the ratio of the Insurance services (% of service imports) in Sub-Saharan Africa (developing only) in 2010 to that in 2012?
Your response must be concise. 1.05. What is the ratio of the Insurance services (% of service imports) in Swaziland in 2010 to that in 2012?
Your answer should be very brief. 1.5. What is the ratio of the Insurance services (% of service imports) of Sub-Saharan Africa (developing only) in 2010 to that in 2013?
Offer a terse response. 0.93. What is the ratio of the Insurance services (% of service imports) of Bolivia in 2010 to that in 2013?
Provide a short and direct response. 0.99. What is the ratio of the Insurance services (% of service imports) in Swaziland in 2010 to that in 2013?
Give a very brief answer. 2.39. What is the ratio of the Insurance services (% of service imports) in Sub-Saharan Africa (developing only) in 2011 to that in 2012?
Offer a terse response. 0.98. What is the ratio of the Insurance services (% of service imports) in Bolivia in 2011 to that in 2012?
Provide a short and direct response. 0.94. What is the ratio of the Insurance services (% of service imports) of Swaziland in 2011 to that in 2012?
Ensure brevity in your answer.  0.79. What is the ratio of the Insurance services (% of service imports) in Sub-Saharan Africa (developing only) in 2011 to that in 2013?
Offer a terse response. 0.88. What is the ratio of the Insurance services (% of service imports) of Bolivia in 2011 to that in 2013?
Your response must be concise. 0.93. What is the ratio of the Insurance services (% of service imports) of Swaziland in 2011 to that in 2013?
Offer a very short reply. 1.25. What is the ratio of the Insurance services (% of service imports) in Sub-Saharan Africa (developing only) in 2012 to that in 2013?
Your answer should be very brief. 0.89. What is the ratio of the Insurance services (% of service imports) of Bolivia in 2012 to that in 2013?
Your answer should be compact. 0.98. What is the ratio of the Insurance services (% of service imports) of Swaziland in 2012 to that in 2013?
Offer a very short reply. 1.6. What is the difference between the highest and the second highest Insurance services (% of service imports) in Sub-Saharan Africa (developing only)?
Give a very brief answer. 0.86. What is the difference between the highest and the second highest Insurance services (% of service imports) of Bolivia?
Provide a succinct answer. 1.67. What is the difference between the highest and the second highest Insurance services (% of service imports) in Swaziland?
Provide a succinct answer. 5.08. What is the difference between the highest and the lowest Insurance services (% of service imports) in Sub-Saharan Africa (developing only)?
Your answer should be compact. 1.6. What is the difference between the highest and the lowest Insurance services (% of service imports) of Bolivia?
Your answer should be very brief. 2.65. What is the difference between the highest and the lowest Insurance services (% of service imports) of Swaziland?
Offer a terse response. 15.58. 